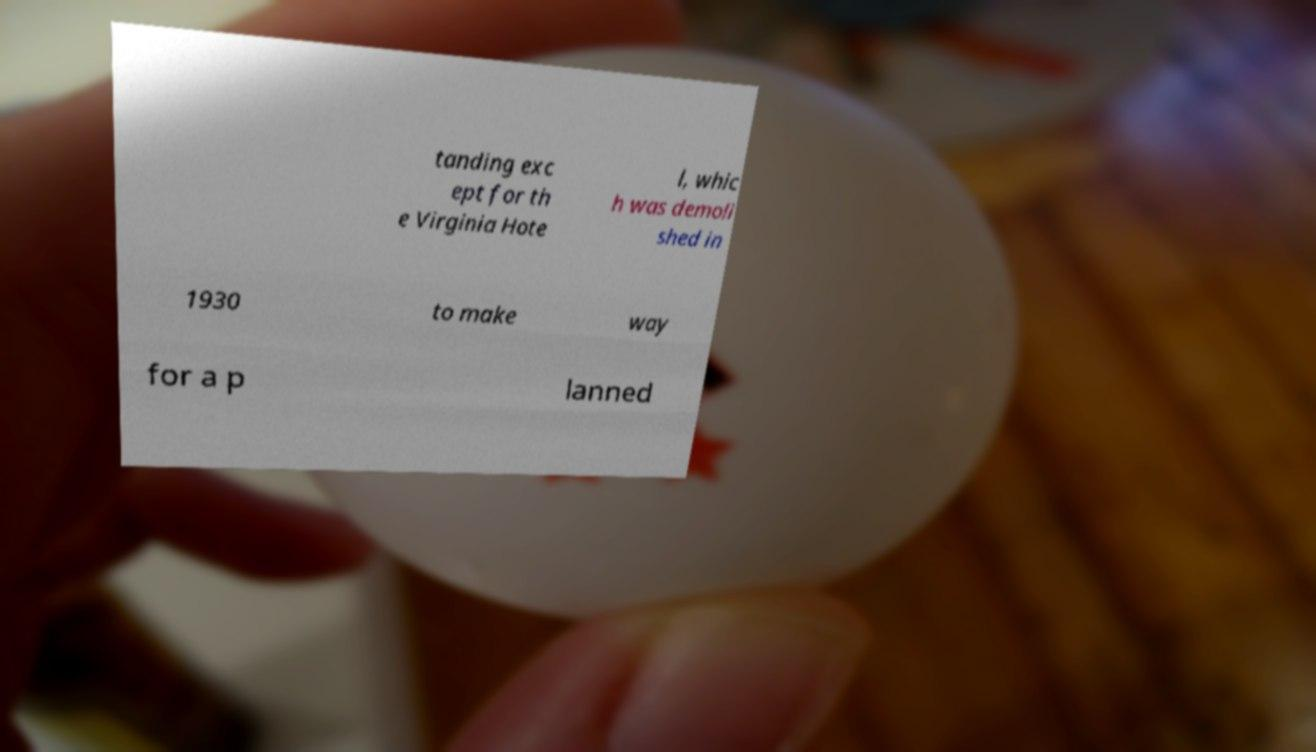Please identify and transcribe the text found in this image. tanding exc ept for th e Virginia Hote l, whic h was demoli shed in 1930 to make way for a p lanned 